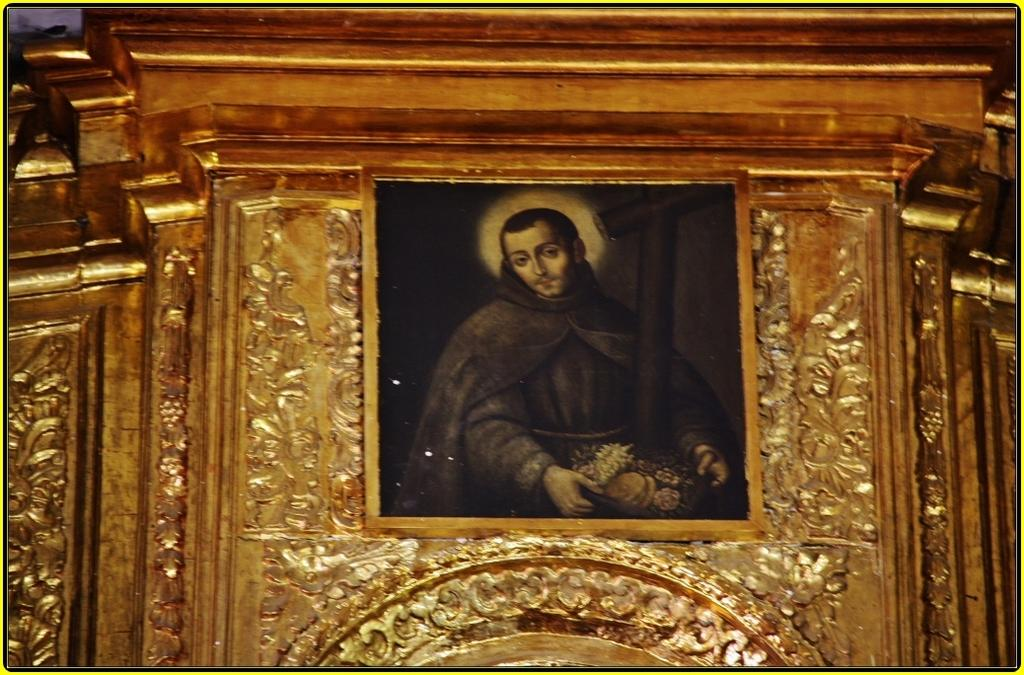What is the main object in the image? There is a frame in the image. What is the frame placed on? The frame is on a golden object. Who or what can be seen inside the frame? There is a person in the frame. What is the person doing in the image? The person is holding objects in their hands. What type of boot is the person wearing in the image? There is no boot visible in the image, as the person is inside a frame and not wearing any footwear. 